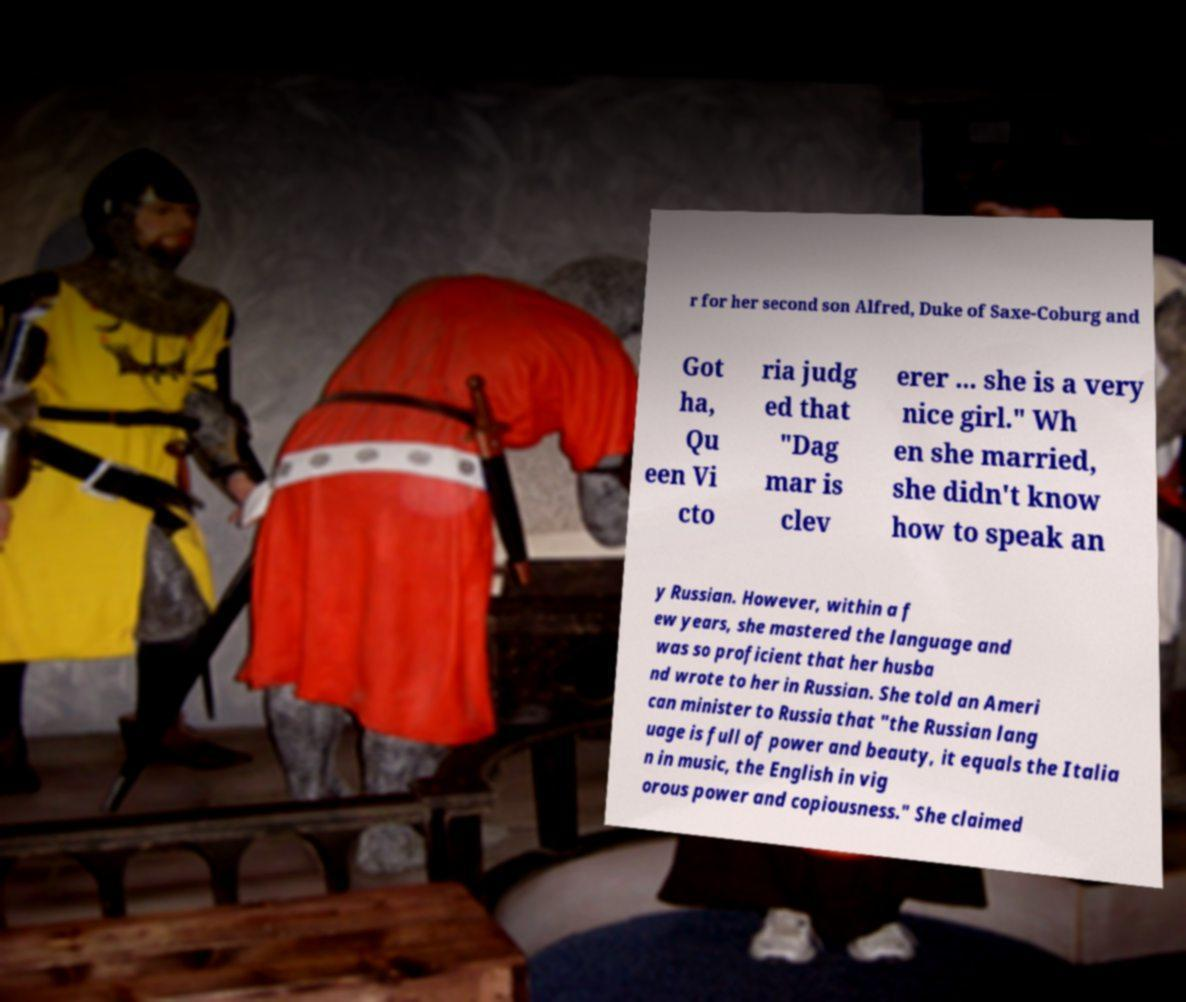For documentation purposes, I need the text within this image transcribed. Could you provide that? r for her second son Alfred, Duke of Saxe-Coburg and Got ha, Qu een Vi cto ria judg ed that "Dag mar is clev erer ... she is a very nice girl." Wh en she married, she didn't know how to speak an y Russian. However, within a f ew years, she mastered the language and was so proficient that her husba nd wrote to her in Russian. She told an Ameri can minister to Russia that "the Russian lang uage is full of power and beauty, it equals the Italia n in music, the English in vig orous power and copiousness." She claimed 